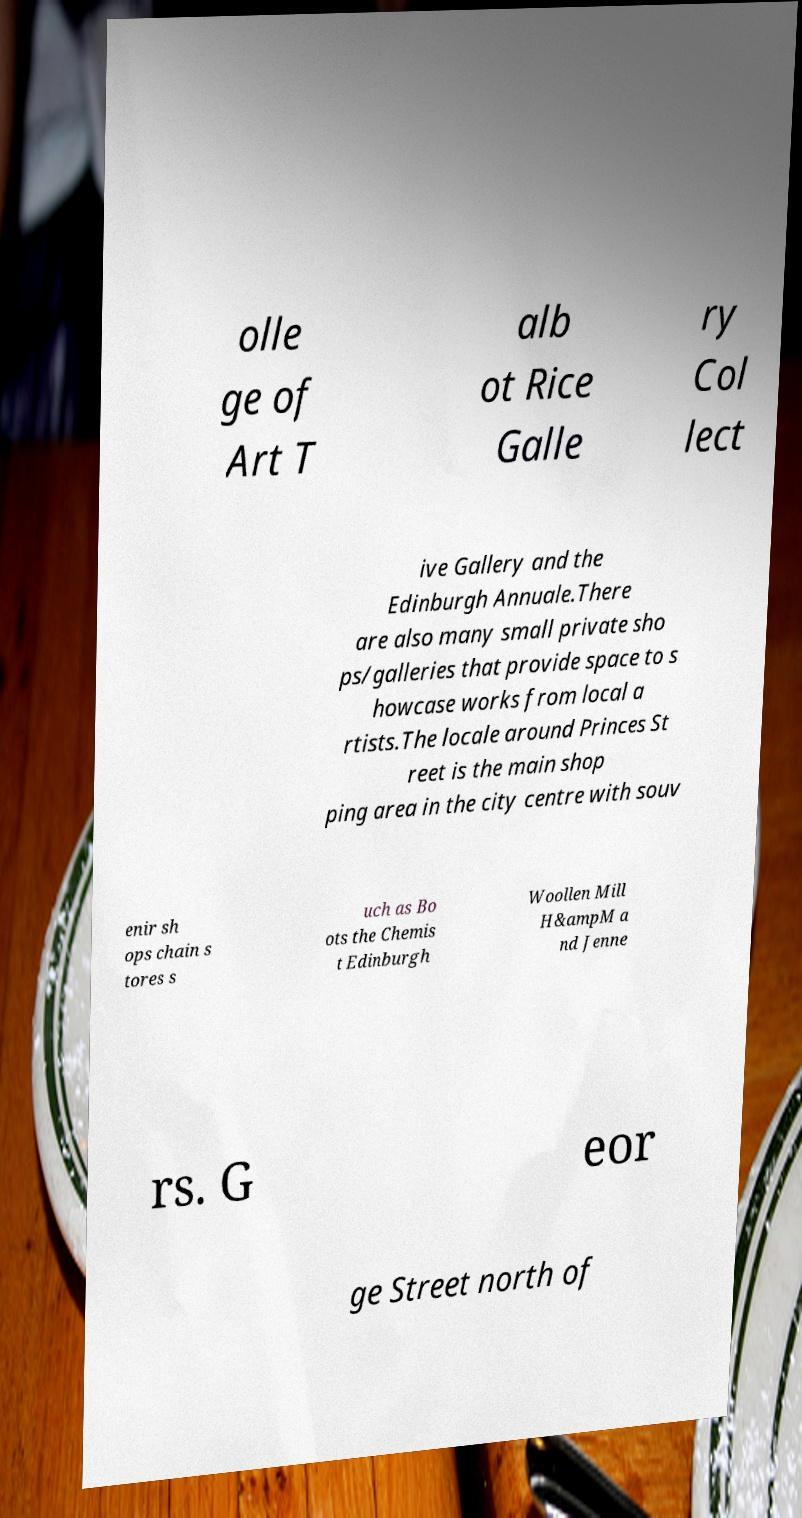There's text embedded in this image that I need extracted. Can you transcribe it verbatim? olle ge of Art T alb ot Rice Galle ry Col lect ive Gallery and the Edinburgh Annuale.There are also many small private sho ps/galleries that provide space to s howcase works from local a rtists.The locale around Princes St reet is the main shop ping area in the city centre with souv enir sh ops chain s tores s uch as Bo ots the Chemis t Edinburgh Woollen Mill H&ampM a nd Jenne rs. G eor ge Street north of 